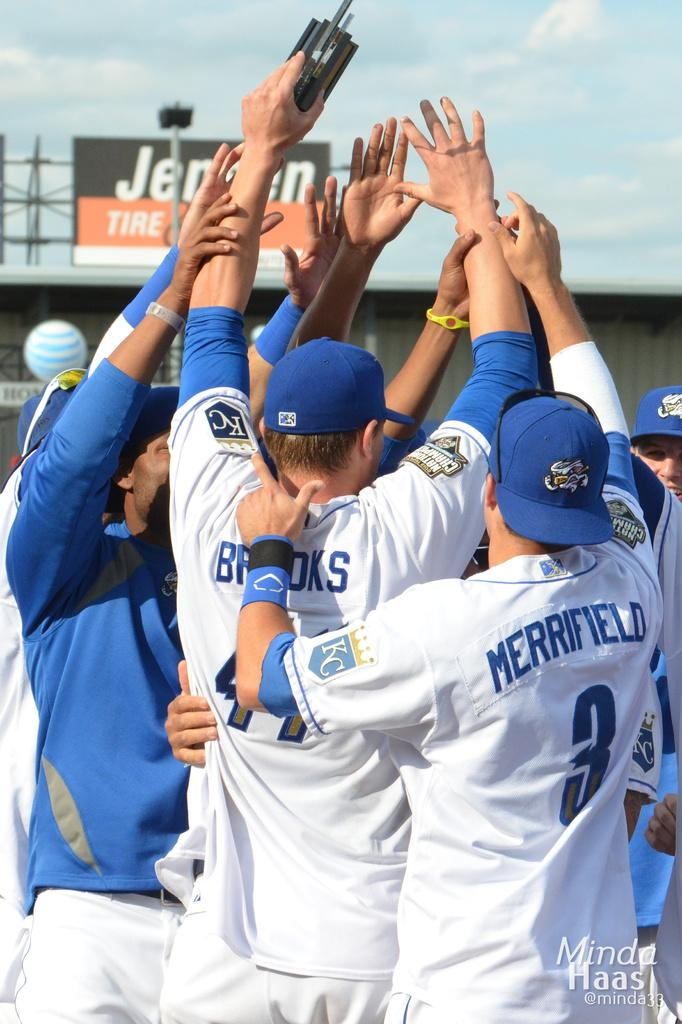<image>
Describe the image concisely. Merrifield and Brooks are players whose team just won the game. 